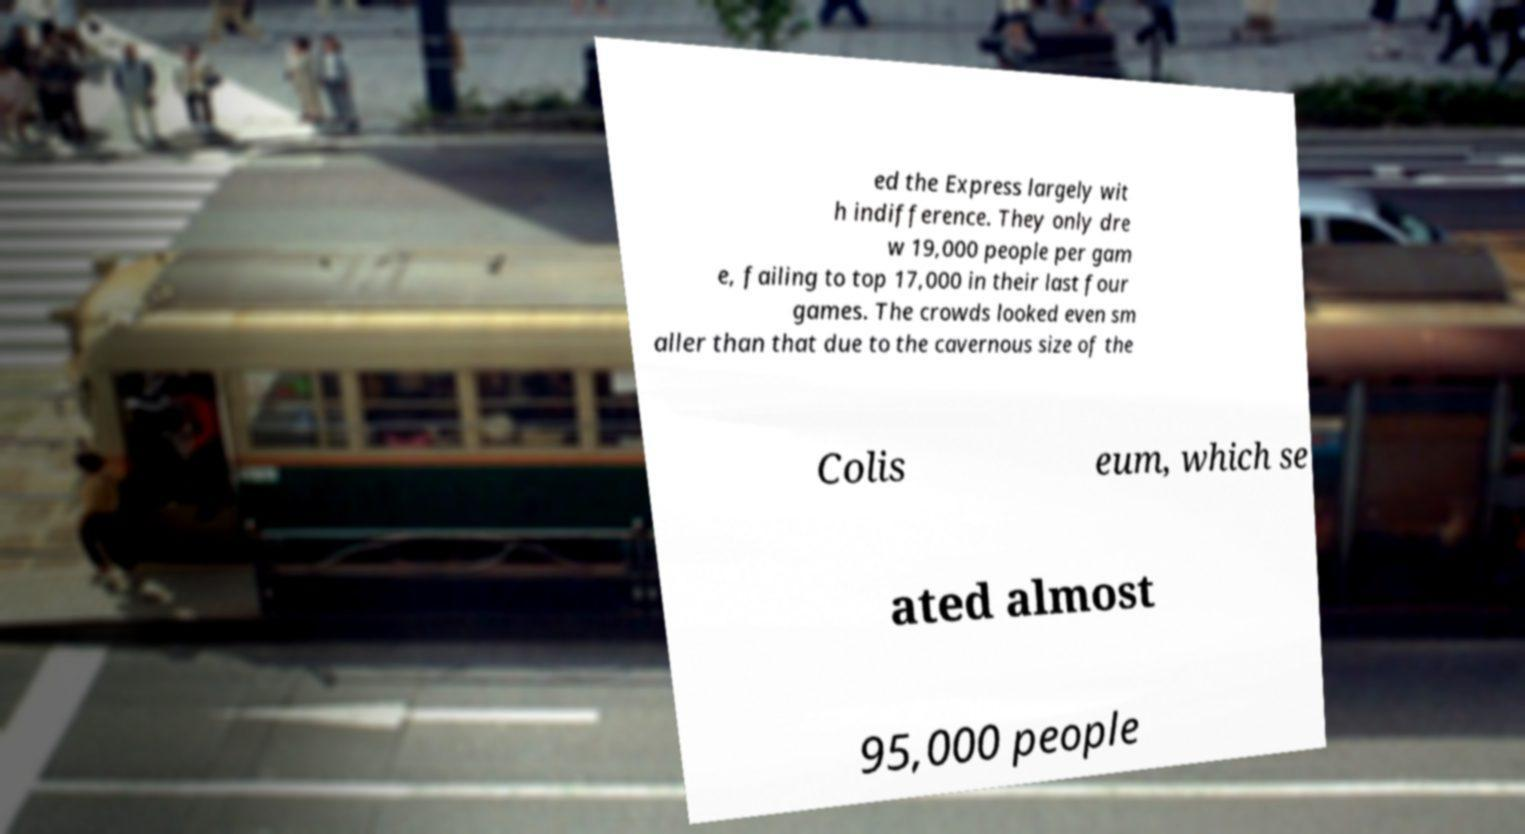Please identify and transcribe the text found in this image. ed the Express largely wit h indifference. They only dre w 19,000 people per gam e, failing to top 17,000 in their last four games. The crowds looked even sm aller than that due to the cavernous size of the Colis eum, which se ated almost 95,000 people 